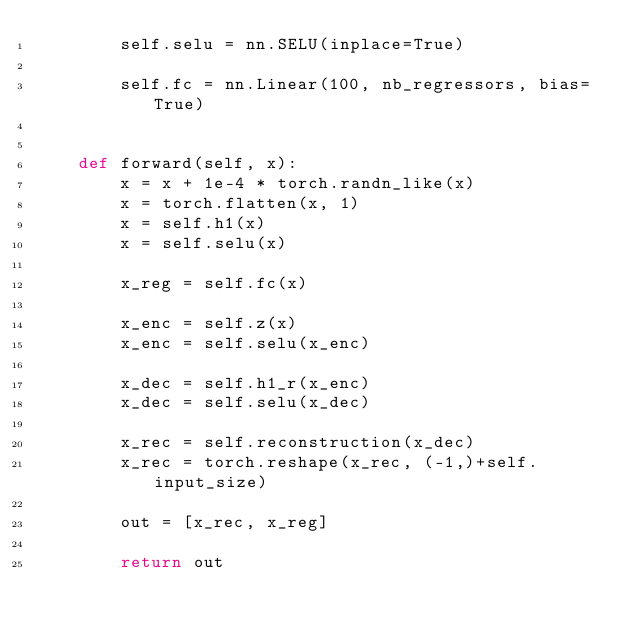<code> <loc_0><loc_0><loc_500><loc_500><_Python_>        self.selu = nn.SELU(inplace=True)

        self.fc = nn.Linear(100, nb_regressors, bias=True)


    def forward(self, x):
        x = x + 1e-4 * torch.randn_like(x)
        x = torch.flatten(x, 1)
        x = self.h1(x)
        x = self.selu(x)

        x_reg = self.fc(x)

        x_enc = self.z(x)
        x_enc = self.selu(x_enc)

        x_dec = self.h1_r(x_enc)
        x_dec = self.selu(x_dec)

        x_rec = self.reconstruction(x_dec)
        x_rec = torch.reshape(x_rec, (-1,)+self.input_size)

        out = [x_rec, x_reg]

        return out


</code> 